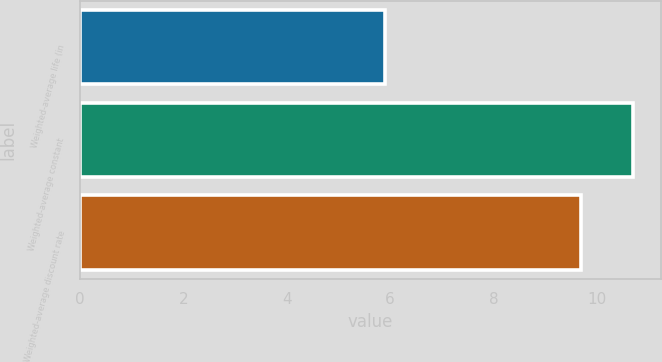Convert chart. <chart><loc_0><loc_0><loc_500><loc_500><bar_chart><fcel>Weighted-average life (in<fcel>Weighted-average constant<fcel>Weighted-average discount rate<nl><fcel>5.9<fcel>10.7<fcel>9.7<nl></chart> 